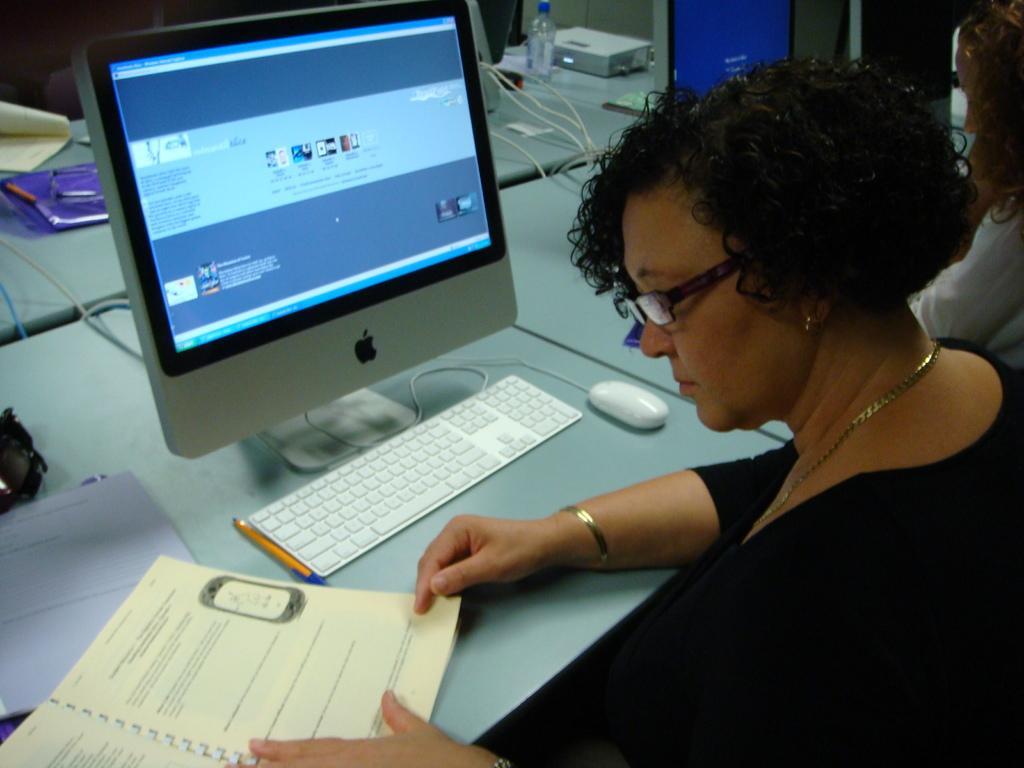In one or two sentences, can you explain what this image depicts? In this picture we can see two women. There is a woman holding a book on the right side. We can see a few computers, keyboard, mouse, bottle,pencil,paper, device, file and other objects. 